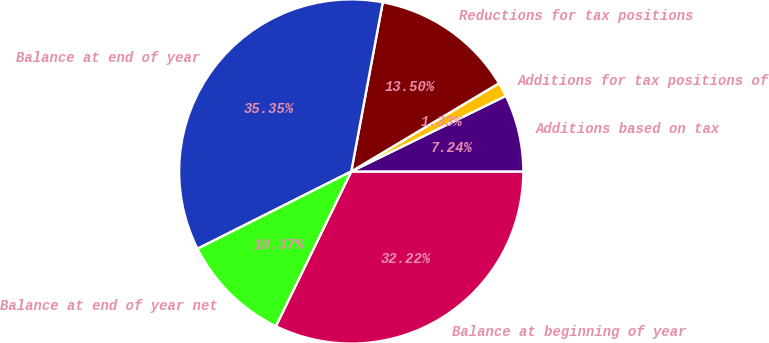<chart> <loc_0><loc_0><loc_500><loc_500><pie_chart><fcel>Balance at beginning of year<fcel>Additions based on tax<fcel>Additions for tax positions of<fcel>Reductions for tax positions<fcel>Balance at end of year<fcel>Balance at end of year net<nl><fcel>32.22%<fcel>7.24%<fcel>1.33%<fcel>13.5%<fcel>35.35%<fcel>10.37%<nl></chart> 